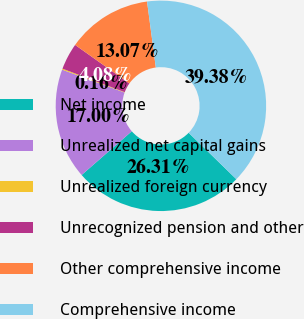Convert chart to OTSL. <chart><loc_0><loc_0><loc_500><loc_500><pie_chart><fcel>Net income<fcel>Unrealized net capital gains<fcel>Unrealized foreign currency<fcel>Unrecognized pension and other<fcel>Other comprehensive income<fcel>Comprehensive income<nl><fcel>26.31%<fcel>17.0%<fcel>0.16%<fcel>4.08%<fcel>13.07%<fcel>39.38%<nl></chart> 